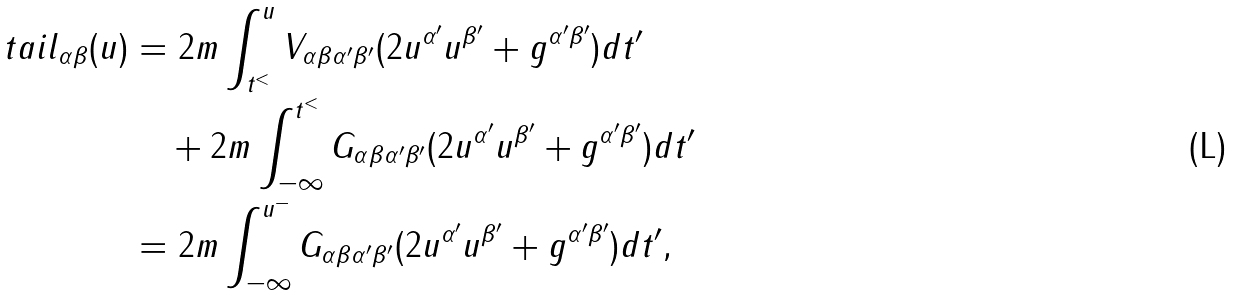<formula> <loc_0><loc_0><loc_500><loc_500>\ t a i l _ { \alpha \beta } ( u ) & = 2 m \int _ { t ^ { < } } ^ { u } V _ { \alpha \beta \alpha ^ { \prime } \beta ^ { \prime } } ( 2 u ^ { \alpha ^ { \prime } } u ^ { \beta ^ { \prime } } + g ^ { \alpha ^ { \prime } \beta ^ { \prime } } ) d t ^ { \prime } \\ & \quad + 2 m \int ^ { t ^ { < } } _ { - \infty } G _ { \alpha \beta \alpha ^ { \prime } \beta ^ { \prime } } ( 2 u ^ { \alpha ^ { \prime } } u ^ { \beta ^ { \prime } } + g ^ { \alpha ^ { \prime } \beta ^ { \prime } } ) d t ^ { \prime } \\ & = 2 m \int _ { - \infty } ^ { u ^ { - } } G _ { \alpha \beta \alpha ^ { \prime } \beta ^ { \prime } } ( 2 u ^ { \alpha ^ { \prime } } u ^ { \beta ^ { \prime } } + g ^ { \alpha ^ { \prime } \beta ^ { \prime } } ) d t ^ { \prime } ,</formula> 